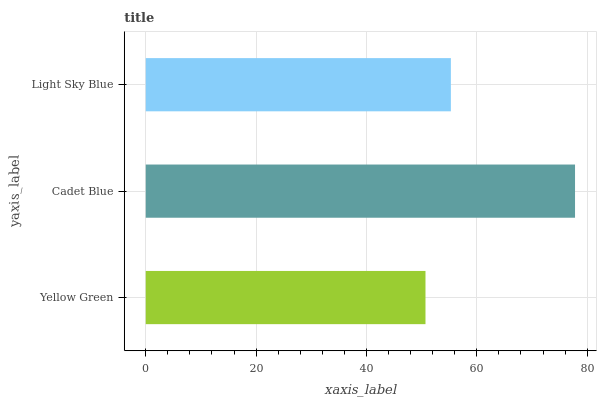Is Yellow Green the minimum?
Answer yes or no. Yes. Is Cadet Blue the maximum?
Answer yes or no. Yes. Is Light Sky Blue the minimum?
Answer yes or no. No. Is Light Sky Blue the maximum?
Answer yes or no. No. Is Cadet Blue greater than Light Sky Blue?
Answer yes or no. Yes. Is Light Sky Blue less than Cadet Blue?
Answer yes or no. Yes. Is Light Sky Blue greater than Cadet Blue?
Answer yes or no. No. Is Cadet Blue less than Light Sky Blue?
Answer yes or no. No. Is Light Sky Blue the high median?
Answer yes or no. Yes. Is Light Sky Blue the low median?
Answer yes or no. Yes. Is Yellow Green the high median?
Answer yes or no. No. Is Yellow Green the low median?
Answer yes or no. No. 